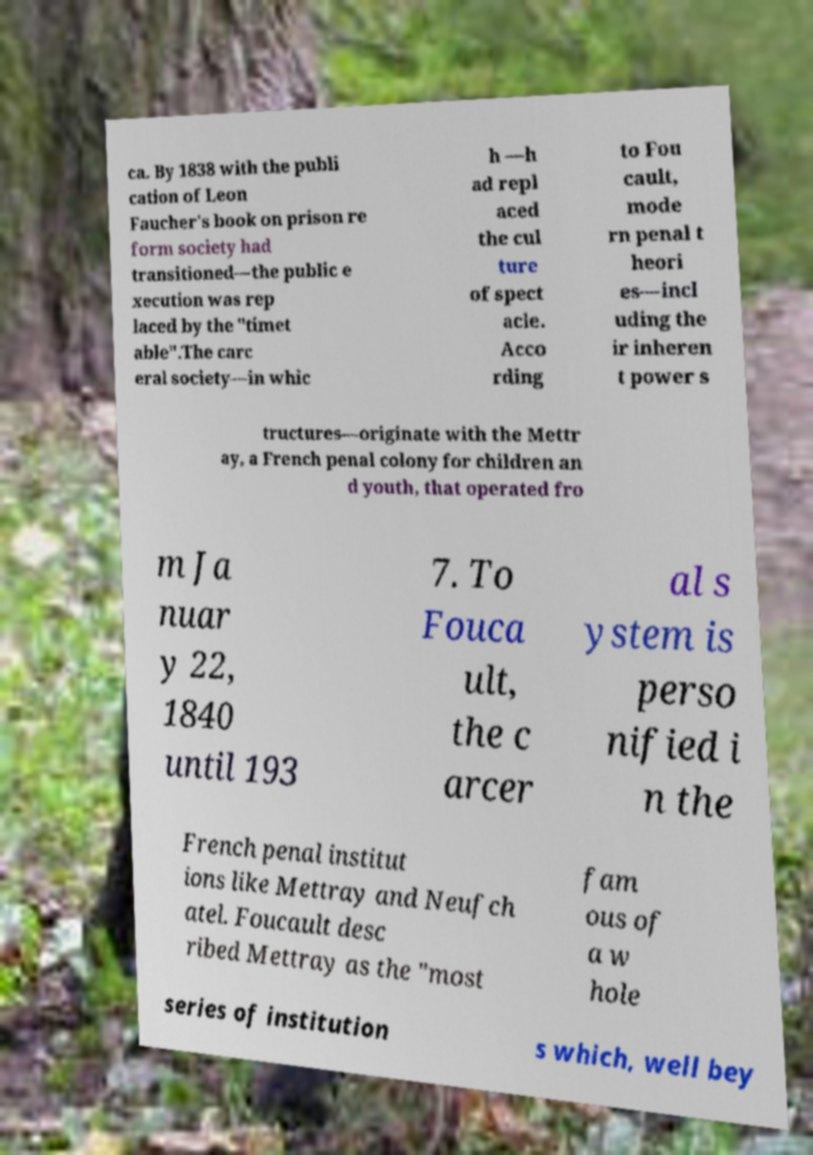Could you extract and type out the text from this image? ca. By 1838 with the publi cation of Leon Faucher's book on prison re form society had transitioned—the public e xecution was rep laced by the "timet able".The carc eral society—in whic h —h ad repl aced the cul ture of spect acle. Acco rding to Fou cault, mode rn penal t heori es—incl uding the ir inheren t power s tructures—originate with the Mettr ay, a French penal colony for children an d youth, that operated fro m Ja nuar y 22, 1840 until 193 7. To Fouca ult, the c arcer al s ystem is perso nified i n the French penal institut ions like Mettray and Neufch atel. Foucault desc ribed Mettray as the "most fam ous of a w hole series of institution s which, well bey 